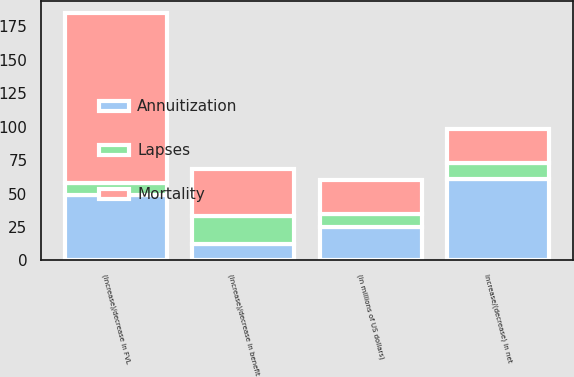Convert chart to OTSL. <chart><loc_0><loc_0><loc_500><loc_500><stacked_bar_chart><ecel><fcel>(in millions of US dollars)<fcel>(Increase)/decrease in benefit<fcel>(Increase)/decrease in FVL<fcel>Increase/(decrease) in net<nl><fcel>Lapses<fcel>10<fcel>21<fcel>9<fcel>12<nl><fcel>Mortality<fcel>25<fcel>35<fcel>127<fcel>25<nl><fcel>Annuitization<fcel>25<fcel>12<fcel>49<fcel>61<nl></chart> 